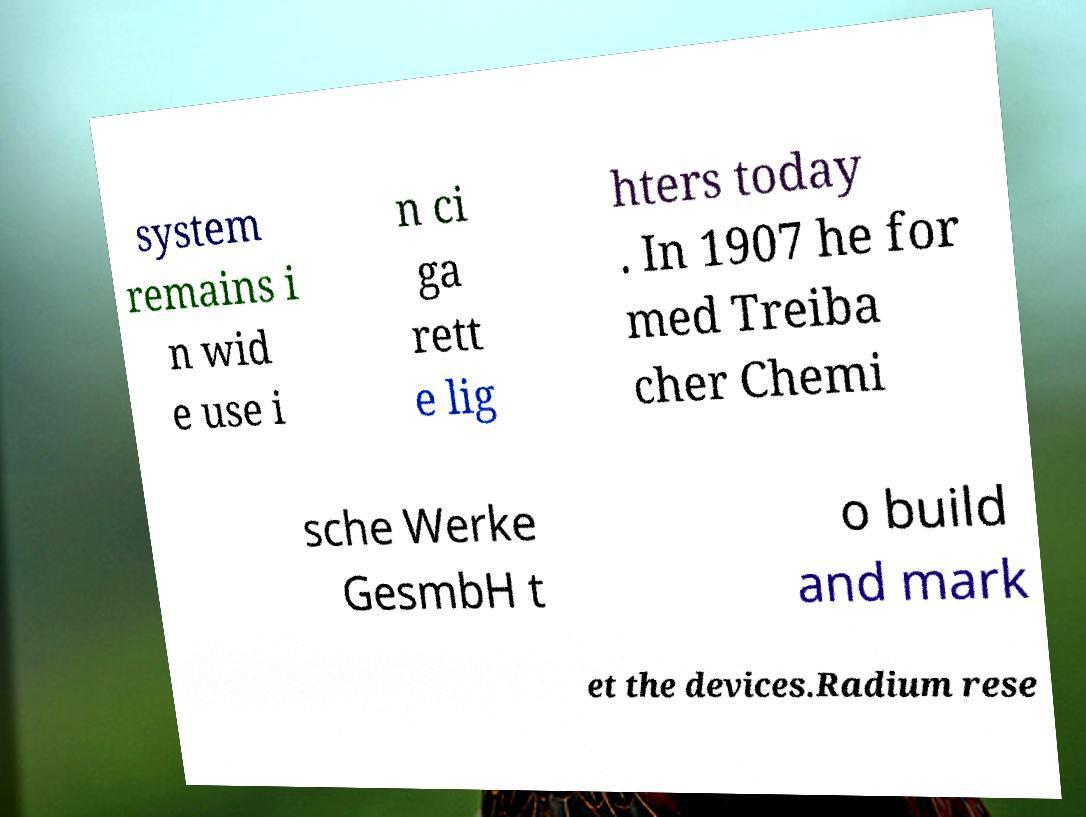What messages or text are displayed in this image? I need them in a readable, typed format. system remains i n wid e use i n ci ga rett e lig hters today . In 1907 he for med Treiba cher Chemi sche Werke GesmbH t o build and mark et the devices.Radium rese 